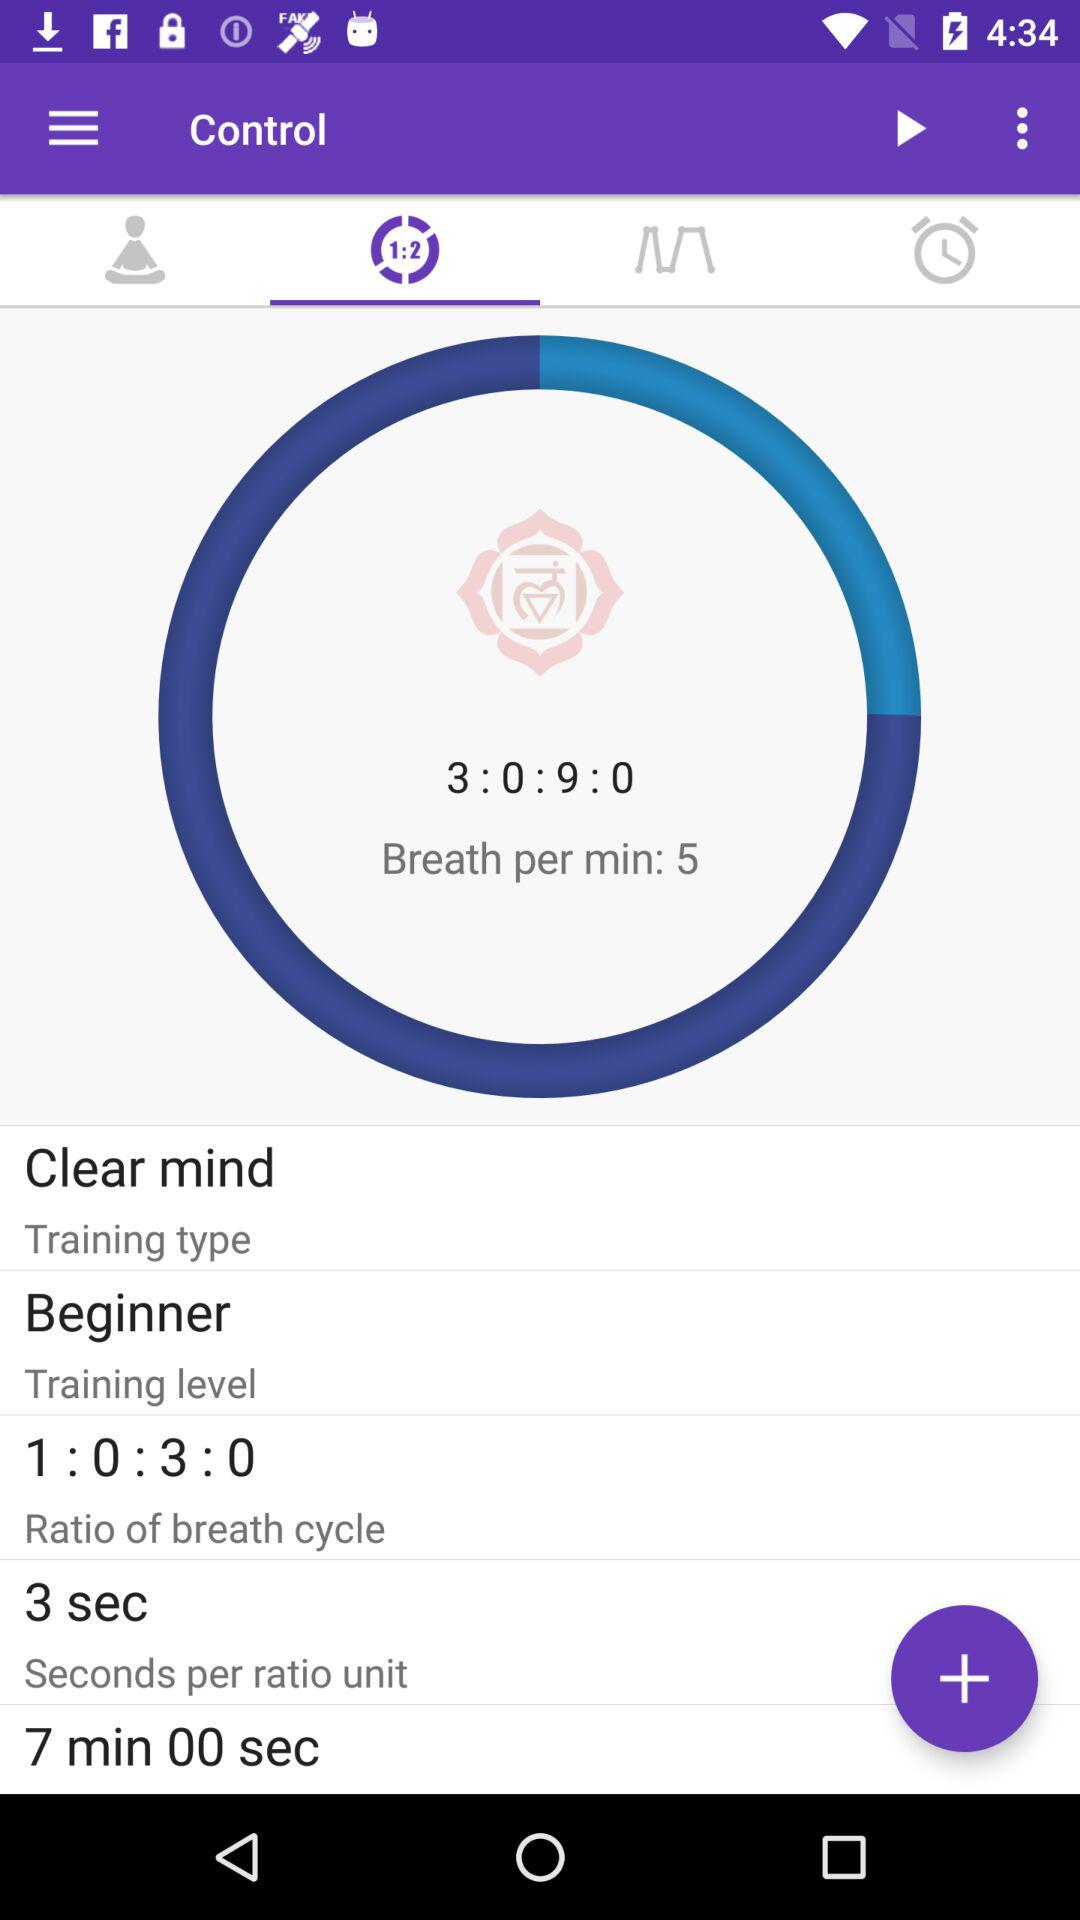What is the "Breath per min"? The "Breath per min" is 5. 